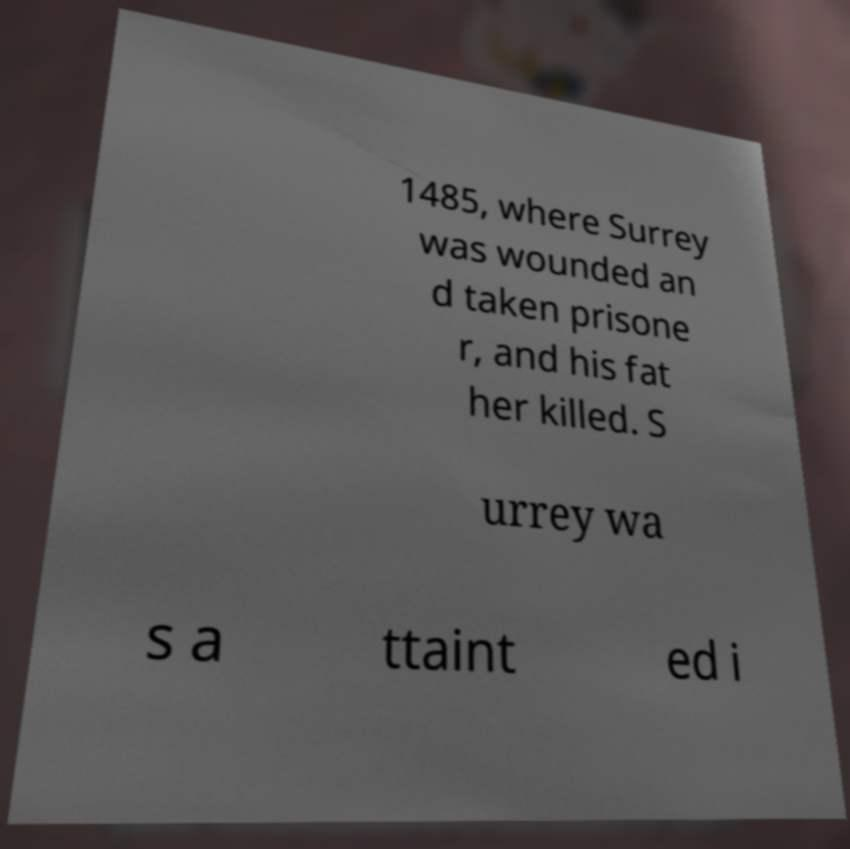Please read and relay the text visible in this image. What does it say? 1485, where Surrey was wounded an d taken prisone r, and his fat her killed. S urrey wa s a ttaint ed i 